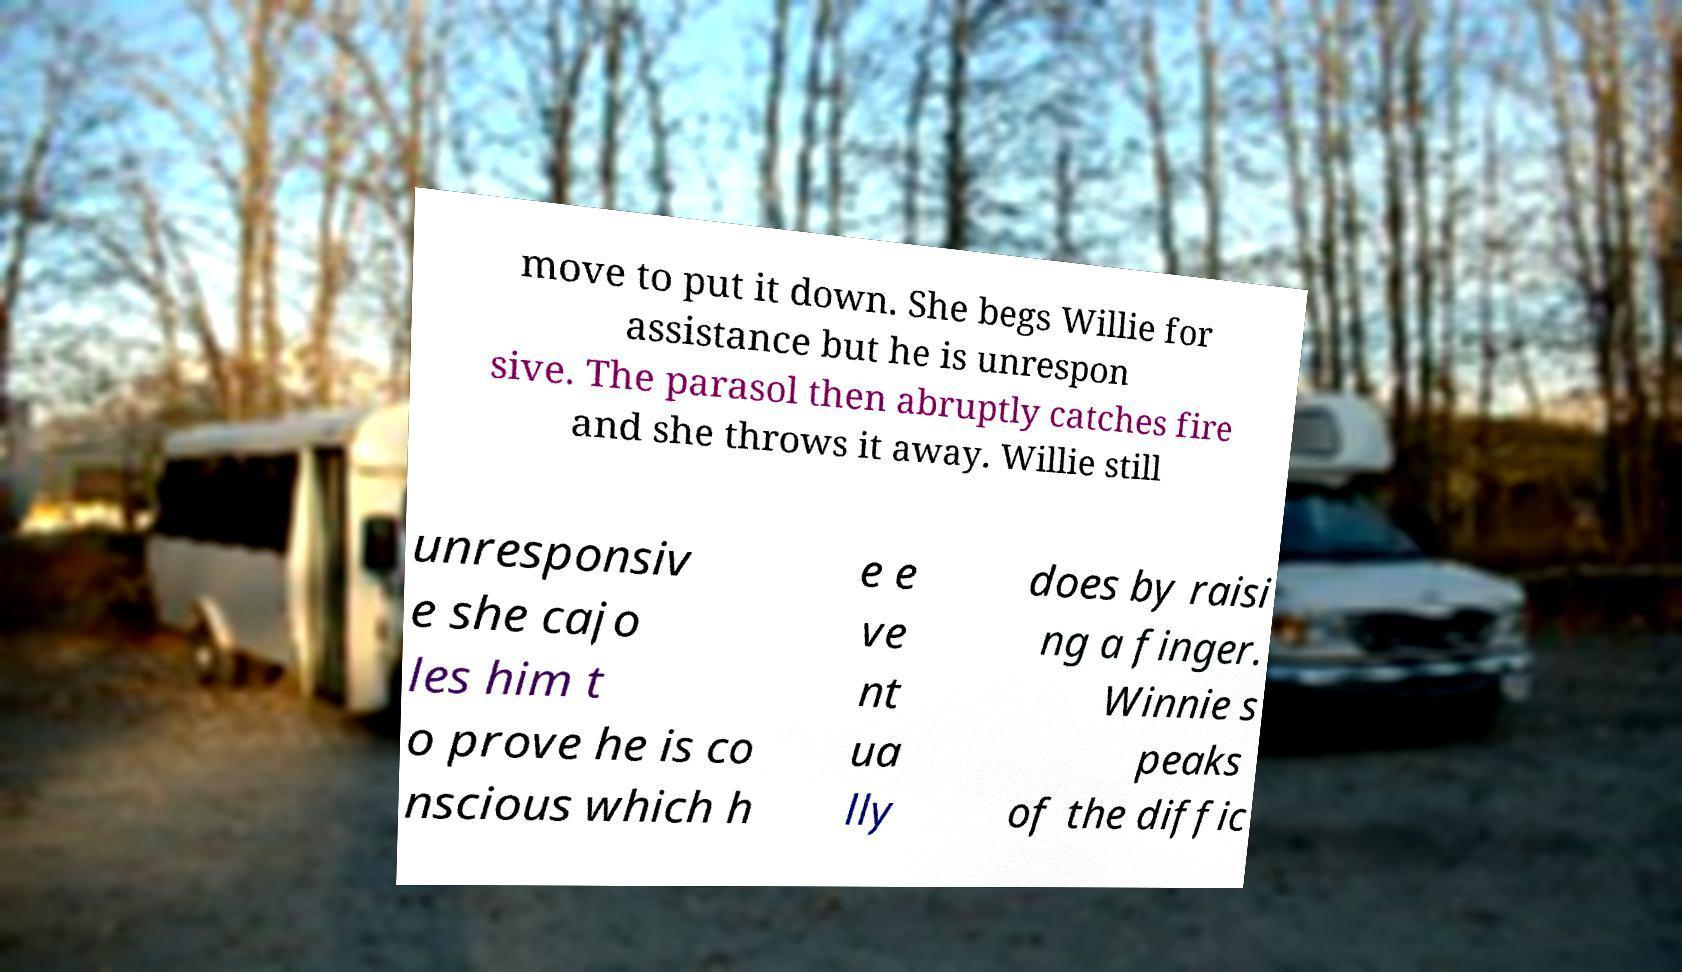Could you extract and type out the text from this image? move to put it down. She begs Willie for assistance but he is unrespon sive. The parasol then abruptly catches fire and she throws it away. Willie still unresponsiv e she cajo les him t o prove he is co nscious which h e e ve nt ua lly does by raisi ng a finger. Winnie s peaks of the diffic 